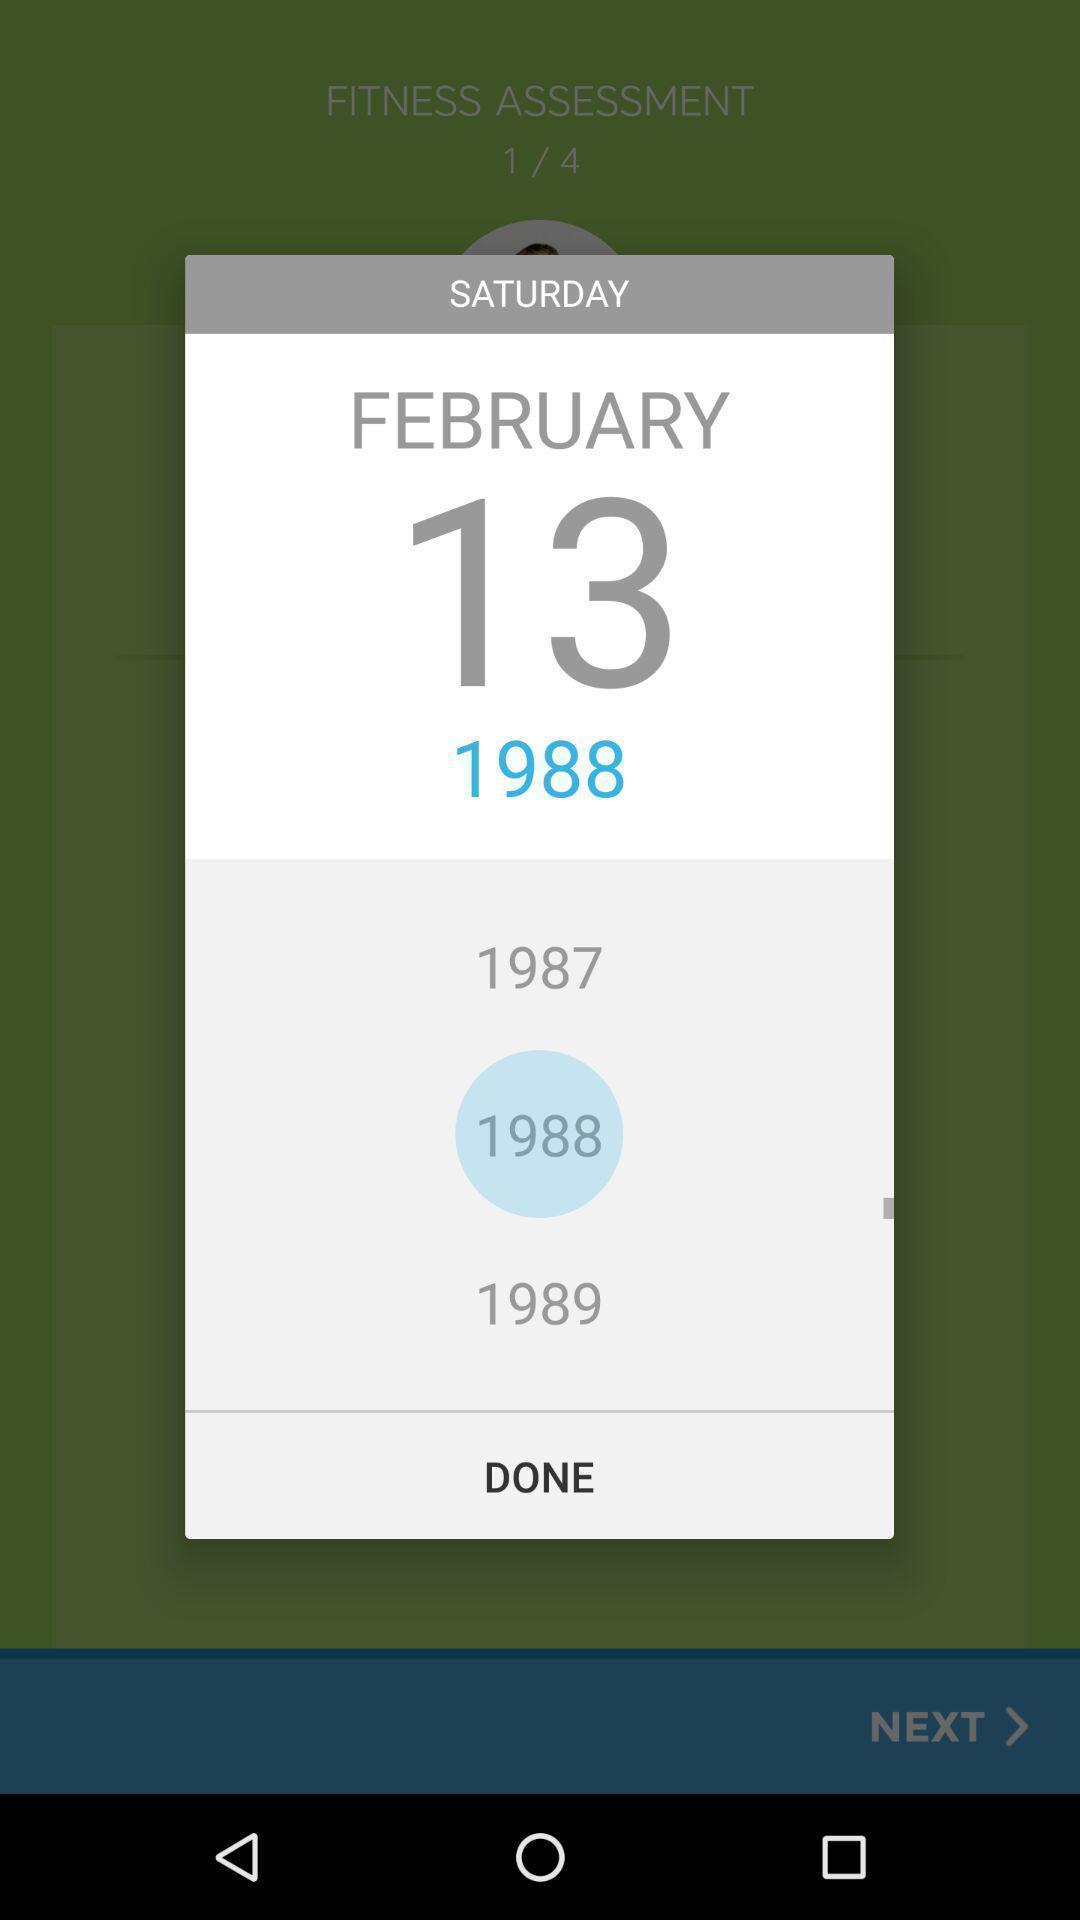Describe the visual elements of this screenshot. Pop-up shows date with done option. 